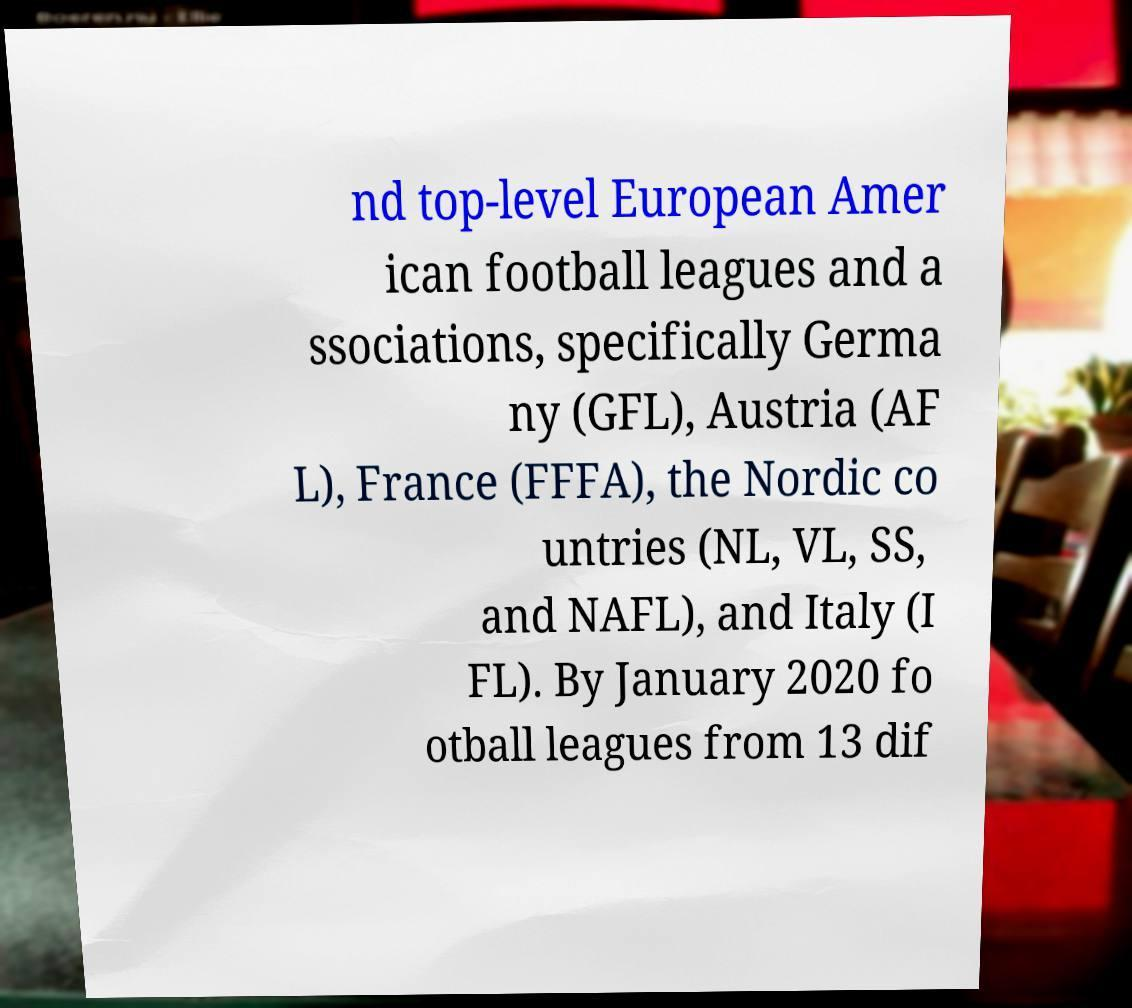Please read and relay the text visible in this image. What does it say? nd top-level European Amer ican football leagues and a ssociations, specifically Germa ny (GFL), Austria (AF L), France (FFFA), the Nordic co untries (NL, VL, SS, and NAFL), and Italy (I FL). By January 2020 fo otball leagues from 13 dif 